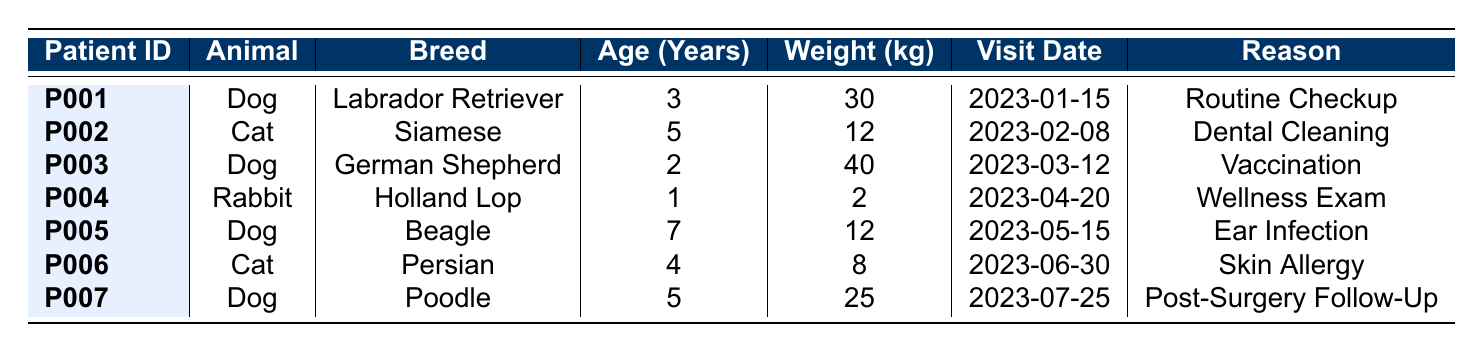What is the weight of the German Shepherd? In the table, locate the row where the breed is "German Shepherd." The weight of that patient is indicated as 40 kg.
Answer: 40 kg Who is the owner of the Rabbit patient? Find the entry for the Rabbit breed. The owner listed for this patient (Holland Lop) is David Wilson.
Answer: David Wilson Which animal type has the oldest patient? The ages of the patients are: 3 (Dog), 5 (Cat), 2 (Dog), 1 (Rabbit), 7 (Dog), 4 (Cat), and 5 (Dog). The oldest age is 7 years, which belongs to a Dog.
Answer: Dog How many dogs are listed in total? Count the number of entries with "Dog" in the Animal column. There are four entries: Labrador Retriever, German Shepherd, Beagle, and Poodle.
Answer: 4 What was the reason for the visit for patient P006? Look for the row with Patient ID "P006." The reason for the visit is listed as "Skin Allergy."
Answer: Skin Allergy What is the average weight of all patients? The total weights are 30 + 12 + 40 + 2 + 12 + 8 + 25 = 129 kg. There are 7 patients, so the average weight is 129/7 = 18.43 kg.
Answer: 18.43 kg Did any patient visit for a routine checkup? Check the reason for visit for all patients. Yes, patient P001 visited for a routine checkup.
Answer: Yes How many cats were seen for dental issues? From the table, only patient P002 (a Cat) visited for "Dental Cleaning," so there is one cat seen for dental issues.
Answer: 1 What is the combined weight of all dogs? The weights of the dogs are 30 (Labrador Retriever) + 40 (German Shepherd) + 12 (Beagle) + 25 (Poodle) = 107 kg.
Answer: 107 kg Which dog breed visited for an ear infection? Review the "Reason for Visit" for each dog. The Beagle (patient P005) visited for an ear infection.
Answer: Beagle 